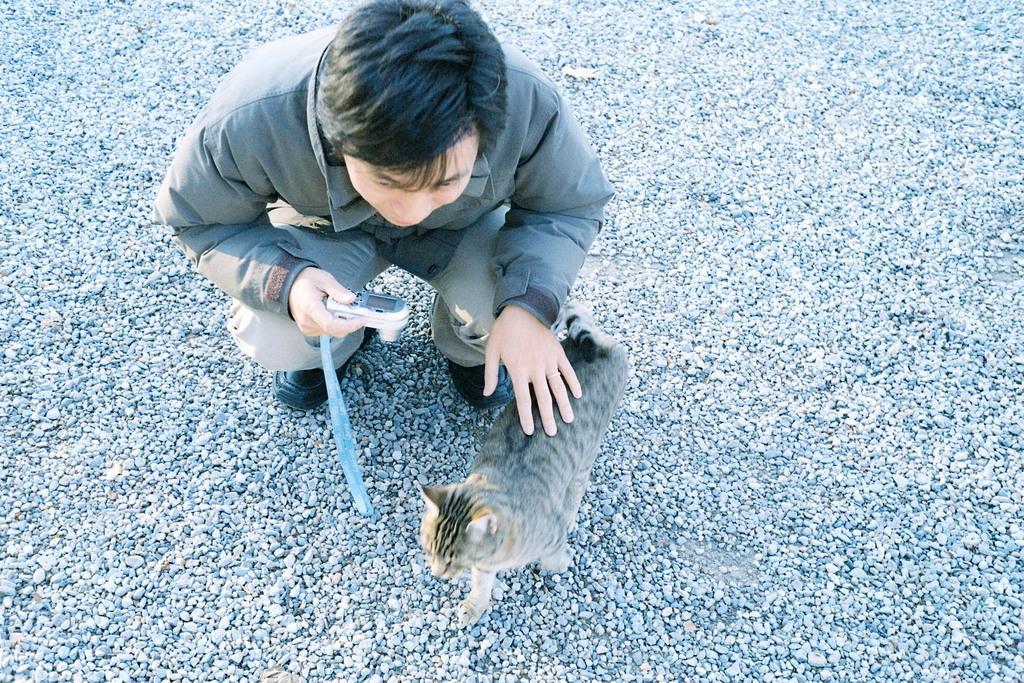Describe this image in one or two sentences. In this picture we can see a man holding a camera with his hand and in front of him we can see a cat, stoned on the ground. 